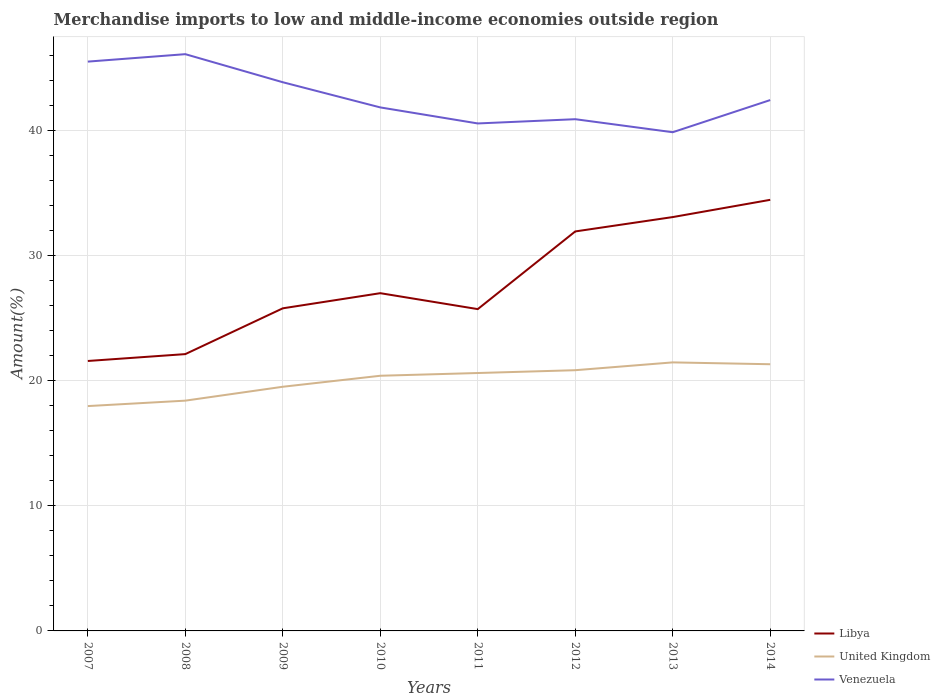Across all years, what is the maximum percentage of amount earned from merchandise imports in Libya?
Provide a short and direct response. 21.59. What is the total percentage of amount earned from merchandise imports in United Kingdom in the graph?
Your answer should be compact. -0.22. What is the difference between the highest and the second highest percentage of amount earned from merchandise imports in Libya?
Offer a terse response. 12.89. What is the difference between the highest and the lowest percentage of amount earned from merchandise imports in Libya?
Make the answer very short. 3. Is the percentage of amount earned from merchandise imports in United Kingdom strictly greater than the percentage of amount earned from merchandise imports in Libya over the years?
Make the answer very short. Yes. How many lines are there?
Your answer should be compact. 3. What is the difference between two consecutive major ticks on the Y-axis?
Make the answer very short. 10. What is the title of the graph?
Give a very brief answer. Merchandise imports to low and middle-income economies outside region. Does "High income: OECD" appear as one of the legend labels in the graph?
Keep it short and to the point. No. What is the label or title of the Y-axis?
Keep it short and to the point. Amount(%). What is the Amount(%) in Libya in 2007?
Offer a very short reply. 21.59. What is the Amount(%) in United Kingdom in 2007?
Offer a very short reply. 17.98. What is the Amount(%) in Venezuela in 2007?
Ensure brevity in your answer.  45.54. What is the Amount(%) of Libya in 2008?
Give a very brief answer. 22.14. What is the Amount(%) in United Kingdom in 2008?
Provide a short and direct response. 18.42. What is the Amount(%) of Venezuela in 2008?
Make the answer very short. 46.13. What is the Amount(%) of Libya in 2009?
Provide a short and direct response. 25.81. What is the Amount(%) in United Kingdom in 2009?
Your response must be concise. 19.53. What is the Amount(%) of Venezuela in 2009?
Offer a very short reply. 43.89. What is the Amount(%) in Libya in 2010?
Your answer should be compact. 27.02. What is the Amount(%) of United Kingdom in 2010?
Your answer should be very brief. 20.41. What is the Amount(%) of Venezuela in 2010?
Provide a short and direct response. 41.87. What is the Amount(%) of Libya in 2011?
Provide a succinct answer. 25.74. What is the Amount(%) in United Kingdom in 2011?
Provide a succinct answer. 20.63. What is the Amount(%) of Venezuela in 2011?
Your answer should be compact. 40.59. What is the Amount(%) in Libya in 2012?
Offer a terse response. 31.95. What is the Amount(%) in United Kingdom in 2012?
Your response must be concise. 20.85. What is the Amount(%) of Venezuela in 2012?
Ensure brevity in your answer.  40.93. What is the Amount(%) of Libya in 2013?
Your answer should be compact. 33.1. What is the Amount(%) in United Kingdom in 2013?
Offer a very short reply. 21.48. What is the Amount(%) in Venezuela in 2013?
Your answer should be very brief. 39.89. What is the Amount(%) of Libya in 2014?
Offer a very short reply. 34.48. What is the Amount(%) in United Kingdom in 2014?
Provide a succinct answer. 21.33. What is the Amount(%) of Venezuela in 2014?
Keep it short and to the point. 42.46. Across all years, what is the maximum Amount(%) of Libya?
Give a very brief answer. 34.48. Across all years, what is the maximum Amount(%) in United Kingdom?
Give a very brief answer. 21.48. Across all years, what is the maximum Amount(%) of Venezuela?
Your answer should be compact. 46.13. Across all years, what is the minimum Amount(%) in Libya?
Your answer should be very brief. 21.59. Across all years, what is the minimum Amount(%) of United Kingdom?
Ensure brevity in your answer.  17.98. Across all years, what is the minimum Amount(%) of Venezuela?
Provide a short and direct response. 39.89. What is the total Amount(%) of Libya in the graph?
Provide a short and direct response. 221.84. What is the total Amount(%) of United Kingdom in the graph?
Keep it short and to the point. 160.64. What is the total Amount(%) in Venezuela in the graph?
Keep it short and to the point. 341.31. What is the difference between the Amount(%) in Libya in 2007 and that in 2008?
Provide a succinct answer. -0.55. What is the difference between the Amount(%) in United Kingdom in 2007 and that in 2008?
Ensure brevity in your answer.  -0.43. What is the difference between the Amount(%) of Venezuela in 2007 and that in 2008?
Keep it short and to the point. -0.59. What is the difference between the Amount(%) of Libya in 2007 and that in 2009?
Your response must be concise. -4.21. What is the difference between the Amount(%) of United Kingdom in 2007 and that in 2009?
Make the answer very short. -1.55. What is the difference between the Amount(%) in Venezuela in 2007 and that in 2009?
Offer a very short reply. 1.65. What is the difference between the Amount(%) in Libya in 2007 and that in 2010?
Provide a succinct answer. -5.42. What is the difference between the Amount(%) in United Kingdom in 2007 and that in 2010?
Offer a terse response. -2.43. What is the difference between the Amount(%) of Venezuela in 2007 and that in 2010?
Provide a short and direct response. 3.66. What is the difference between the Amount(%) of Libya in 2007 and that in 2011?
Offer a terse response. -4.15. What is the difference between the Amount(%) in United Kingdom in 2007 and that in 2011?
Your answer should be very brief. -2.64. What is the difference between the Amount(%) in Venezuela in 2007 and that in 2011?
Your answer should be very brief. 4.95. What is the difference between the Amount(%) of Libya in 2007 and that in 2012?
Your response must be concise. -10.36. What is the difference between the Amount(%) in United Kingdom in 2007 and that in 2012?
Give a very brief answer. -2.87. What is the difference between the Amount(%) in Venezuela in 2007 and that in 2012?
Keep it short and to the point. 4.61. What is the difference between the Amount(%) of Libya in 2007 and that in 2013?
Ensure brevity in your answer.  -11.51. What is the difference between the Amount(%) in United Kingdom in 2007 and that in 2013?
Your answer should be compact. -3.49. What is the difference between the Amount(%) in Venezuela in 2007 and that in 2013?
Your answer should be compact. 5.65. What is the difference between the Amount(%) of Libya in 2007 and that in 2014?
Make the answer very short. -12.89. What is the difference between the Amount(%) in United Kingdom in 2007 and that in 2014?
Your response must be concise. -3.35. What is the difference between the Amount(%) in Venezuela in 2007 and that in 2014?
Give a very brief answer. 3.08. What is the difference between the Amount(%) of Libya in 2008 and that in 2009?
Make the answer very short. -3.66. What is the difference between the Amount(%) in United Kingdom in 2008 and that in 2009?
Give a very brief answer. -1.11. What is the difference between the Amount(%) in Venezuela in 2008 and that in 2009?
Offer a very short reply. 2.24. What is the difference between the Amount(%) of Libya in 2008 and that in 2010?
Your response must be concise. -4.87. What is the difference between the Amount(%) of United Kingdom in 2008 and that in 2010?
Make the answer very short. -1.99. What is the difference between the Amount(%) in Venezuela in 2008 and that in 2010?
Your response must be concise. 4.26. What is the difference between the Amount(%) in Libya in 2008 and that in 2011?
Keep it short and to the point. -3.6. What is the difference between the Amount(%) in United Kingdom in 2008 and that in 2011?
Ensure brevity in your answer.  -2.21. What is the difference between the Amount(%) of Venezuela in 2008 and that in 2011?
Your answer should be compact. 5.54. What is the difference between the Amount(%) of Libya in 2008 and that in 2012?
Provide a short and direct response. -9.81. What is the difference between the Amount(%) in United Kingdom in 2008 and that in 2012?
Make the answer very short. -2.44. What is the difference between the Amount(%) of Venezuela in 2008 and that in 2012?
Your answer should be compact. 5.2. What is the difference between the Amount(%) of Libya in 2008 and that in 2013?
Your answer should be compact. -10.96. What is the difference between the Amount(%) of United Kingdom in 2008 and that in 2013?
Ensure brevity in your answer.  -3.06. What is the difference between the Amount(%) of Venezuela in 2008 and that in 2013?
Provide a short and direct response. 6.24. What is the difference between the Amount(%) of Libya in 2008 and that in 2014?
Offer a terse response. -12.34. What is the difference between the Amount(%) in United Kingdom in 2008 and that in 2014?
Provide a succinct answer. -2.91. What is the difference between the Amount(%) of Venezuela in 2008 and that in 2014?
Make the answer very short. 3.67. What is the difference between the Amount(%) in Libya in 2009 and that in 2010?
Make the answer very short. -1.21. What is the difference between the Amount(%) of United Kingdom in 2009 and that in 2010?
Offer a terse response. -0.88. What is the difference between the Amount(%) of Venezuela in 2009 and that in 2010?
Ensure brevity in your answer.  2.01. What is the difference between the Amount(%) in Libya in 2009 and that in 2011?
Ensure brevity in your answer.  0.06. What is the difference between the Amount(%) in United Kingdom in 2009 and that in 2011?
Keep it short and to the point. -1.1. What is the difference between the Amount(%) in Venezuela in 2009 and that in 2011?
Keep it short and to the point. 3.3. What is the difference between the Amount(%) of Libya in 2009 and that in 2012?
Your answer should be compact. -6.15. What is the difference between the Amount(%) of United Kingdom in 2009 and that in 2012?
Offer a terse response. -1.32. What is the difference between the Amount(%) in Venezuela in 2009 and that in 2012?
Keep it short and to the point. 2.96. What is the difference between the Amount(%) in Libya in 2009 and that in 2013?
Give a very brief answer. -7.3. What is the difference between the Amount(%) of United Kingdom in 2009 and that in 2013?
Keep it short and to the point. -1.95. What is the difference between the Amount(%) of Venezuela in 2009 and that in 2013?
Your answer should be very brief. 4. What is the difference between the Amount(%) in Libya in 2009 and that in 2014?
Your response must be concise. -8.68. What is the difference between the Amount(%) of United Kingdom in 2009 and that in 2014?
Your answer should be compact. -1.8. What is the difference between the Amount(%) of Venezuela in 2009 and that in 2014?
Your answer should be very brief. 1.43. What is the difference between the Amount(%) of Libya in 2010 and that in 2011?
Your answer should be very brief. 1.27. What is the difference between the Amount(%) of United Kingdom in 2010 and that in 2011?
Your answer should be very brief. -0.22. What is the difference between the Amount(%) of Venezuela in 2010 and that in 2011?
Provide a succinct answer. 1.28. What is the difference between the Amount(%) in Libya in 2010 and that in 2012?
Offer a terse response. -4.94. What is the difference between the Amount(%) of United Kingdom in 2010 and that in 2012?
Give a very brief answer. -0.44. What is the difference between the Amount(%) of Venezuela in 2010 and that in 2012?
Your answer should be compact. 0.94. What is the difference between the Amount(%) of Libya in 2010 and that in 2013?
Keep it short and to the point. -6.09. What is the difference between the Amount(%) in United Kingdom in 2010 and that in 2013?
Provide a short and direct response. -1.07. What is the difference between the Amount(%) of Venezuela in 2010 and that in 2013?
Your answer should be compact. 1.98. What is the difference between the Amount(%) in Libya in 2010 and that in 2014?
Ensure brevity in your answer.  -7.47. What is the difference between the Amount(%) in United Kingdom in 2010 and that in 2014?
Your answer should be compact. -0.92. What is the difference between the Amount(%) in Venezuela in 2010 and that in 2014?
Your answer should be compact. -0.59. What is the difference between the Amount(%) in Libya in 2011 and that in 2012?
Offer a terse response. -6.21. What is the difference between the Amount(%) of United Kingdom in 2011 and that in 2012?
Ensure brevity in your answer.  -0.23. What is the difference between the Amount(%) of Venezuela in 2011 and that in 2012?
Provide a succinct answer. -0.34. What is the difference between the Amount(%) in Libya in 2011 and that in 2013?
Provide a short and direct response. -7.36. What is the difference between the Amount(%) in United Kingdom in 2011 and that in 2013?
Provide a succinct answer. -0.85. What is the difference between the Amount(%) in Venezuela in 2011 and that in 2013?
Your answer should be very brief. 0.7. What is the difference between the Amount(%) of Libya in 2011 and that in 2014?
Offer a very short reply. -8.74. What is the difference between the Amount(%) of United Kingdom in 2011 and that in 2014?
Offer a very short reply. -0.7. What is the difference between the Amount(%) in Venezuela in 2011 and that in 2014?
Provide a short and direct response. -1.87. What is the difference between the Amount(%) in Libya in 2012 and that in 2013?
Give a very brief answer. -1.15. What is the difference between the Amount(%) of United Kingdom in 2012 and that in 2013?
Provide a short and direct response. -0.62. What is the difference between the Amount(%) of Venezuela in 2012 and that in 2013?
Offer a very short reply. 1.04. What is the difference between the Amount(%) in Libya in 2012 and that in 2014?
Your answer should be compact. -2.53. What is the difference between the Amount(%) in United Kingdom in 2012 and that in 2014?
Provide a short and direct response. -0.48. What is the difference between the Amount(%) in Venezuela in 2012 and that in 2014?
Your answer should be very brief. -1.53. What is the difference between the Amount(%) in Libya in 2013 and that in 2014?
Your answer should be very brief. -1.38. What is the difference between the Amount(%) of United Kingdom in 2013 and that in 2014?
Your answer should be very brief. 0.15. What is the difference between the Amount(%) of Venezuela in 2013 and that in 2014?
Offer a very short reply. -2.57. What is the difference between the Amount(%) of Libya in 2007 and the Amount(%) of United Kingdom in 2008?
Give a very brief answer. 3.17. What is the difference between the Amount(%) in Libya in 2007 and the Amount(%) in Venezuela in 2008?
Give a very brief answer. -24.54. What is the difference between the Amount(%) of United Kingdom in 2007 and the Amount(%) of Venezuela in 2008?
Your answer should be very brief. -28.15. What is the difference between the Amount(%) in Libya in 2007 and the Amount(%) in United Kingdom in 2009?
Make the answer very short. 2.06. What is the difference between the Amount(%) in Libya in 2007 and the Amount(%) in Venezuela in 2009?
Make the answer very short. -22.3. What is the difference between the Amount(%) of United Kingdom in 2007 and the Amount(%) of Venezuela in 2009?
Provide a short and direct response. -25.9. What is the difference between the Amount(%) of Libya in 2007 and the Amount(%) of United Kingdom in 2010?
Make the answer very short. 1.18. What is the difference between the Amount(%) in Libya in 2007 and the Amount(%) in Venezuela in 2010?
Offer a terse response. -20.28. What is the difference between the Amount(%) in United Kingdom in 2007 and the Amount(%) in Venezuela in 2010?
Your answer should be very brief. -23.89. What is the difference between the Amount(%) in Libya in 2007 and the Amount(%) in United Kingdom in 2011?
Provide a short and direct response. 0.96. What is the difference between the Amount(%) of Libya in 2007 and the Amount(%) of Venezuela in 2011?
Give a very brief answer. -19. What is the difference between the Amount(%) in United Kingdom in 2007 and the Amount(%) in Venezuela in 2011?
Keep it short and to the point. -22.61. What is the difference between the Amount(%) of Libya in 2007 and the Amount(%) of United Kingdom in 2012?
Offer a terse response. 0.74. What is the difference between the Amount(%) in Libya in 2007 and the Amount(%) in Venezuela in 2012?
Offer a terse response. -19.34. What is the difference between the Amount(%) of United Kingdom in 2007 and the Amount(%) of Venezuela in 2012?
Ensure brevity in your answer.  -22.95. What is the difference between the Amount(%) of Libya in 2007 and the Amount(%) of United Kingdom in 2013?
Your response must be concise. 0.11. What is the difference between the Amount(%) of Libya in 2007 and the Amount(%) of Venezuela in 2013?
Provide a succinct answer. -18.3. What is the difference between the Amount(%) in United Kingdom in 2007 and the Amount(%) in Venezuela in 2013?
Keep it short and to the point. -21.91. What is the difference between the Amount(%) of Libya in 2007 and the Amount(%) of United Kingdom in 2014?
Your answer should be compact. 0.26. What is the difference between the Amount(%) in Libya in 2007 and the Amount(%) in Venezuela in 2014?
Give a very brief answer. -20.87. What is the difference between the Amount(%) of United Kingdom in 2007 and the Amount(%) of Venezuela in 2014?
Provide a succinct answer. -24.48. What is the difference between the Amount(%) of Libya in 2008 and the Amount(%) of United Kingdom in 2009?
Your answer should be very brief. 2.61. What is the difference between the Amount(%) of Libya in 2008 and the Amount(%) of Venezuela in 2009?
Your response must be concise. -21.75. What is the difference between the Amount(%) of United Kingdom in 2008 and the Amount(%) of Venezuela in 2009?
Your answer should be very brief. -25.47. What is the difference between the Amount(%) in Libya in 2008 and the Amount(%) in United Kingdom in 2010?
Provide a short and direct response. 1.73. What is the difference between the Amount(%) in Libya in 2008 and the Amount(%) in Venezuela in 2010?
Your answer should be compact. -19.73. What is the difference between the Amount(%) of United Kingdom in 2008 and the Amount(%) of Venezuela in 2010?
Provide a short and direct response. -23.46. What is the difference between the Amount(%) of Libya in 2008 and the Amount(%) of United Kingdom in 2011?
Your response must be concise. 1.51. What is the difference between the Amount(%) of Libya in 2008 and the Amount(%) of Venezuela in 2011?
Provide a succinct answer. -18.45. What is the difference between the Amount(%) of United Kingdom in 2008 and the Amount(%) of Venezuela in 2011?
Your answer should be compact. -22.17. What is the difference between the Amount(%) of Libya in 2008 and the Amount(%) of United Kingdom in 2012?
Your response must be concise. 1.29. What is the difference between the Amount(%) in Libya in 2008 and the Amount(%) in Venezuela in 2012?
Make the answer very short. -18.79. What is the difference between the Amount(%) of United Kingdom in 2008 and the Amount(%) of Venezuela in 2012?
Your answer should be very brief. -22.51. What is the difference between the Amount(%) of Libya in 2008 and the Amount(%) of United Kingdom in 2013?
Make the answer very short. 0.66. What is the difference between the Amount(%) of Libya in 2008 and the Amount(%) of Venezuela in 2013?
Ensure brevity in your answer.  -17.75. What is the difference between the Amount(%) in United Kingdom in 2008 and the Amount(%) in Venezuela in 2013?
Keep it short and to the point. -21.47. What is the difference between the Amount(%) of Libya in 2008 and the Amount(%) of United Kingdom in 2014?
Offer a very short reply. 0.81. What is the difference between the Amount(%) in Libya in 2008 and the Amount(%) in Venezuela in 2014?
Provide a short and direct response. -20.32. What is the difference between the Amount(%) of United Kingdom in 2008 and the Amount(%) of Venezuela in 2014?
Offer a very short reply. -24.04. What is the difference between the Amount(%) in Libya in 2009 and the Amount(%) in United Kingdom in 2010?
Your answer should be very brief. 5.39. What is the difference between the Amount(%) of Libya in 2009 and the Amount(%) of Venezuela in 2010?
Your answer should be very brief. -16.07. What is the difference between the Amount(%) of United Kingdom in 2009 and the Amount(%) of Venezuela in 2010?
Offer a very short reply. -22.34. What is the difference between the Amount(%) in Libya in 2009 and the Amount(%) in United Kingdom in 2011?
Your response must be concise. 5.18. What is the difference between the Amount(%) in Libya in 2009 and the Amount(%) in Venezuela in 2011?
Provide a succinct answer. -14.79. What is the difference between the Amount(%) of United Kingdom in 2009 and the Amount(%) of Venezuela in 2011?
Ensure brevity in your answer.  -21.06. What is the difference between the Amount(%) of Libya in 2009 and the Amount(%) of United Kingdom in 2012?
Keep it short and to the point. 4.95. What is the difference between the Amount(%) in Libya in 2009 and the Amount(%) in Venezuela in 2012?
Ensure brevity in your answer.  -15.13. What is the difference between the Amount(%) in United Kingdom in 2009 and the Amount(%) in Venezuela in 2012?
Provide a short and direct response. -21.4. What is the difference between the Amount(%) in Libya in 2009 and the Amount(%) in United Kingdom in 2013?
Your answer should be very brief. 4.33. What is the difference between the Amount(%) of Libya in 2009 and the Amount(%) of Venezuela in 2013?
Make the answer very short. -14.09. What is the difference between the Amount(%) in United Kingdom in 2009 and the Amount(%) in Venezuela in 2013?
Offer a very short reply. -20.36. What is the difference between the Amount(%) in Libya in 2009 and the Amount(%) in United Kingdom in 2014?
Make the answer very short. 4.47. What is the difference between the Amount(%) of Libya in 2009 and the Amount(%) of Venezuela in 2014?
Your answer should be very brief. -16.66. What is the difference between the Amount(%) of United Kingdom in 2009 and the Amount(%) of Venezuela in 2014?
Provide a short and direct response. -22.93. What is the difference between the Amount(%) of Libya in 2010 and the Amount(%) of United Kingdom in 2011?
Your answer should be very brief. 6.39. What is the difference between the Amount(%) of Libya in 2010 and the Amount(%) of Venezuela in 2011?
Keep it short and to the point. -13.58. What is the difference between the Amount(%) of United Kingdom in 2010 and the Amount(%) of Venezuela in 2011?
Provide a short and direct response. -20.18. What is the difference between the Amount(%) of Libya in 2010 and the Amount(%) of United Kingdom in 2012?
Make the answer very short. 6.16. What is the difference between the Amount(%) of Libya in 2010 and the Amount(%) of Venezuela in 2012?
Ensure brevity in your answer.  -13.92. What is the difference between the Amount(%) of United Kingdom in 2010 and the Amount(%) of Venezuela in 2012?
Ensure brevity in your answer.  -20.52. What is the difference between the Amount(%) in Libya in 2010 and the Amount(%) in United Kingdom in 2013?
Provide a short and direct response. 5.54. What is the difference between the Amount(%) of Libya in 2010 and the Amount(%) of Venezuela in 2013?
Make the answer very short. -12.87. What is the difference between the Amount(%) in United Kingdom in 2010 and the Amount(%) in Venezuela in 2013?
Your answer should be very brief. -19.48. What is the difference between the Amount(%) in Libya in 2010 and the Amount(%) in United Kingdom in 2014?
Your response must be concise. 5.68. What is the difference between the Amount(%) of Libya in 2010 and the Amount(%) of Venezuela in 2014?
Your response must be concise. -15.45. What is the difference between the Amount(%) of United Kingdom in 2010 and the Amount(%) of Venezuela in 2014?
Offer a terse response. -22.05. What is the difference between the Amount(%) in Libya in 2011 and the Amount(%) in United Kingdom in 2012?
Give a very brief answer. 4.89. What is the difference between the Amount(%) in Libya in 2011 and the Amount(%) in Venezuela in 2012?
Give a very brief answer. -15.19. What is the difference between the Amount(%) in United Kingdom in 2011 and the Amount(%) in Venezuela in 2012?
Your answer should be very brief. -20.3. What is the difference between the Amount(%) of Libya in 2011 and the Amount(%) of United Kingdom in 2013?
Your answer should be compact. 4.26. What is the difference between the Amount(%) of Libya in 2011 and the Amount(%) of Venezuela in 2013?
Offer a terse response. -14.15. What is the difference between the Amount(%) of United Kingdom in 2011 and the Amount(%) of Venezuela in 2013?
Offer a very short reply. -19.26. What is the difference between the Amount(%) in Libya in 2011 and the Amount(%) in United Kingdom in 2014?
Give a very brief answer. 4.41. What is the difference between the Amount(%) of Libya in 2011 and the Amount(%) of Venezuela in 2014?
Offer a terse response. -16.72. What is the difference between the Amount(%) in United Kingdom in 2011 and the Amount(%) in Venezuela in 2014?
Keep it short and to the point. -21.83. What is the difference between the Amount(%) of Libya in 2012 and the Amount(%) of United Kingdom in 2013?
Your answer should be compact. 10.47. What is the difference between the Amount(%) in Libya in 2012 and the Amount(%) in Venezuela in 2013?
Offer a terse response. -7.94. What is the difference between the Amount(%) in United Kingdom in 2012 and the Amount(%) in Venezuela in 2013?
Your answer should be very brief. -19.04. What is the difference between the Amount(%) of Libya in 2012 and the Amount(%) of United Kingdom in 2014?
Offer a terse response. 10.62. What is the difference between the Amount(%) in Libya in 2012 and the Amount(%) in Venezuela in 2014?
Make the answer very short. -10.51. What is the difference between the Amount(%) in United Kingdom in 2012 and the Amount(%) in Venezuela in 2014?
Your answer should be compact. -21.61. What is the difference between the Amount(%) of Libya in 2013 and the Amount(%) of United Kingdom in 2014?
Give a very brief answer. 11.77. What is the difference between the Amount(%) in Libya in 2013 and the Amount(%) in Venezuela in 2014?
Your answer should be compact. -9.36. What is the difference between the Amount(%) of United Kingdom in 2013 and the Amount(%) of Venezuela in 2014?
Your answer should be very brief. -20.98. What is the average Amount(%) of Libya per year?
Your answer should be compact. 27.73. What is the average Amount(%) of United Kingdom per year?
Give a very brief answer. 20.08. What is the average Amount(%) of Venezuela per year?
Provide a short and direct response. 42.66. In the year 2007, what is the difference between the Amount(%) of Libya and Amount(%) of United Kingdom?
Your answer should be compact. 3.61. In the year 2007, what is the difference between the Amount(%) of Libya and Amount(%) of Venezuela?
Make the answer very short. -23.95. In the year 2007, what is the difference between the Amount(%) of United Kingdom and Amount(%) of Venezuela?
Provide a succinct answer. -27.55. In the year 2008, what is the difference between the Amount(%) of Libya and Amount(%) of United Kingdom?
Give a very brief answer. 3.72. In the year 2008, what is the difference between the Amount(%) of Libya and Amount(%) of Venezuela?
Your response must be concise. -23.99. In the year 2008, what is the difference between the Amount(%) of United Kingdom and Amount(%) of Venezuela?
Your answer should be very brief. -27.71. In the year 2009, what is the difference between the Amount(%) of Libya and Amount(%) of United Kingdom?
Your answer should be very brief. 6.27. In the year 2009, what is the difference between the Amount(%) in Libya and Amount(%) in Venezuela?
Keep it short and to the point. -18.08. In the year 2009, what is the difference between the Amount(%) in United Kingdom and Amount(%) in Venezuela?
Provide a succinct answer. -24.36. In the year 2010, what is the difference between the Amount(%) of Libya and Amount(%) of United Kingdom?
Keep it short and to the point. 6.6. In the year 2010, what is the difference between the Amount(%) of Libya and Amount(%) of Venezuela?
Ensure brevity in your answer.  -14.86. In the year 2010, what is the difference between the Amount(%) of United Kingdom and Amount(%) of Venezuela?
Provide a short and direct response. -21.46. In the year 2011, what is the difference between the Amount(%) of Libya and Amount(%) of United Kingdom?
Your answer should be compact. 5.11. In the year 2011, what is the difference between the Amount(%) of Libya and Amount(%) of Venezuela?
Ensure brevity in your answer.  -14.85. In the year 2011, what is the difference between the Amount(%) in United Kingdom and Amount(%) in Venezuela?
Ensure brevity in your answer.  -19.96. In the year 2012, what is the difference between the Amount(%) of Libya and Amount(%) of United Kingdom?
Your response must be concise. 11.1. In the year 2012, what is the difference between the Amount(%) in Libya and Amount(%) in Venezuela?
Your response must be concise. -8.98. In the year 2012, what is the difference between the Amount(%) of United Kingdom and Amount(%) of Venezuela?
Your response must be concise. -20.08. In the year 2013, what is the difference between the Amount(%) in Libya and Amount(%) in United Kingdom?
Provide a short and direct response. 11.62. In the year 2013, what is the difference between the Amount(%) of Libya and Amount(%) of Venezuela?
Your response must be concise. -6.79. In the year 2013, what is the difference between the Amount(%) in United Kingdom and Amount(%) in Venezuela?
Provide a short and direct response. -18.41. In the year 2014, what is the difference between the Amount(%) of Libya and Amount(%) of United Kingdom?
Provide a succinct answer. 13.15. In the year 2014, what is the difference between the Amount(%) of Libya and Amount(%) of Venezuela?
Keep it short and to the point. -7.98. In the year 2014, what is the difference between the Amount(%) of United Kingdom and Amount(%) of Venezuela?
Give a very brief answer. -21.13. What is the ratio of the Amount(%) of Libya in 2007 to that in 2008?
Provide a succinct answer. 0.98. What is the ratio of the Amount(%) in United Kingdom in 2007 to that in 2008?
Your response must be concise. 0.98. What is the ratio of the Amount(%) in Venezuela in 2007 to that in 2008?
Offer a terse response. 0.99. What is the ratio of the Amount(%) in Libya in 2007 to that in 2009?
Make the answer very short. 0.84. What is the ratio of the Amount(%) in United Kingdom in 2007 to that in 2009?
Provide a succinct answer. 0.92. What is the ratio of the Amount(%) in Venezuela in 2007 to that in 2009?
Offer a terse response. 1.04. What is the ratio of the Amount(%) of Libya in 2007 to that in 2010?
Your answer should be compact. 0.8. What is the ratio of the Amount(%) in United Kingdom in 2007 to that in 2010?
Your answer should be compact. 0.88. What is the ratio of the Amount(%) of Venezuela in 2007 to that in 2010?
Your answer should be very brief. 1.09. What is the ratio of the Amount(%) of Libya in 2007 to that in 2011?
Keep it short and to the point. 0.84. What is the ratio of the Amount(%) in United Kingdom in 2007 to that in 2011?
Give a very brief answer. 0.87. What is the ratio of the Amount(%) in Venezuela in 2007 to that in 2011?
Keep it short and to the point. 1.12. What is the ratio of the Amount(%) of Libya in 2007 to that in 2012?
Provide a short and direct response. 0.68. What is the ratio of the Amount(%) of United Kingdom in 2007 to that in 2012?
Offer a terse response. 0.86. What is the ratio of the Amount(%) in Venezuela in 2007 to that in 2012?
Your answer should be very brief. 1.11. What is the ratio of the Amount(%) of Libya in 2007 to that in 2013?
Offer a very short reply. 0.65. What is the ratio of the Amount(%) of United Kingdom in 2007 to that in 2013?
Your answer should be very brief. 0.84. What is the ratio of the Amount(%) in Venezuela in 2007 to that in 2013?
Ensure brevity in your answer.  1.14. What is the ratio of the Amount(%) in Libya in 2007 to that in 2014?
Provide a succinct answer. 0.63. What is the ratio of the Amount(%) of United Kingdom in 2007 to that in 2014?
Provide a succinct answer. 0.84. What is the ratio of the Amount(%) of Venezuela in 2007 to that in 2014?
Give a very brief answer. 1.07. What is the ratio of the Amount(%) in Libya in 2008 to that in 2009?
Keep it short and to the point. 0.86. What is the ratio of the Amount(%) of United Kingdom in 2008 to that in 2009?
Your response must be concise. 0.94. What is the ratio of the Amount(%) of Venezuela in 2008 to that in 2009?
Keep it short and to the point. 1.05. What is the ratio of the Amount(%) in Libya in 2008 to that in 2010?
Give a very brief answer. 0.82. What is the ratio of the Amount(%) of United Kingdom in 2008 to that in 2010?
Offer a terse response. 0.9. What is the ratio of the Amount(%) in Venezuela in 2008 to that in 2010?
Provide a succinct answer. 1.1. What is the ratio of the Amount(%) in Libya in 2008 to that in 2011?
Provide a short and direct response. 0.86. What is the ratio of the Amount(%) of United Kingdom in 2008 to that in 2011?
Keep it short and to the point. 0.89. What is the ratio of the Amount(%) of Venezuela in 2008 to that in 2011?
Give a very brief answer. 1.14. What is the ratio of the Amount(%) of Libya in 2008 to that in 2012?
Give a very brief answer. 0.69. What is the ratio of the Amount(%) of United Kingdom in 2008 to that in 2012?
Provide a short and direct response. 0.88. What is the ratio of the Amount(%) of Venezuela in 2008 to that in 2012?
Keep it short and to the point. 1.13. What is the ratio of the Amount(%) of Libya in 2008 to that in 2013?
Provide a short and direct response. 0.67. What is the ratio of the Amount(%) in United Kingdom in 2008 to that in 2013?
Offer a very short reply. 0.86. What is the ratio of the Amount(%) of Venezuela in 2008 to that in 2013?
Your answer should be compact. 1.16. What is the ratio of the Amount(%) in Libya in 2008 to that in 2014?
Your answer should be very brief. 0.64. What is the ratio of the Amount(%) of United Kingdom in 2008 to that in 2014?
Give a very brief answer. 0.86. What is the ratio of the Amount(%) in Venezuela in 2008 to that in 2014?
Give a very brief answer. 1.09. What is the ratio of the Amount(%) of Libya in 2009 to that in 2010?
Your response must be concise. 0.96. What is the ratio of the Amount(%) of United Kingdom in 2009 to that in 2010?
Your answer should be very brief. 0.96. What is the ratio of the Amount(%) of Venezuela in 2009 to that in 2010?
Make the answer very short. 1.05. What is the ratio of the Amount(%) of Libya in 2009 to that in 2011?
Make the answer very short. 1. What is the ratio of the Amount(%) in United Kingdom in 2009 to that in 2011?
Provide a succinct answer. 0.95. What is the ratio of the Amount(%) of Venezuela in 2009 to that in 2011?
Make the answer very short. 1.08. What is the ratio of the Amount(%) in Libya in 2009 to that in 2012?
Offer a very short reply. 0.81. What is the ratio of the Amount(%) of United Kingdom in 2009 to that in 2012?
Keep it short and to the point. 0.94. What is the ratio of the Amount(%) in Venezuela in 2009 to that in 2012?
Your response must be concise. 1.07. What is the ratio of the Amount(%) in Libya in 2009 to that in 2013?
Offer a terse response. 0.78. What is the ratio of the Amount(%) of United Kingdom in 2009 to that in 2013?
Make the answer very short. 0.91. What is the ratio of the Amount(%) of Venezuela in 2009 to that in 2013?
Your answer should be very brief. 1.1. What is the ratio of the Amount(%) in Libya in 2009 to that in 2014?
Provide a short and direct response. 0.75. What is the ratio of the Amount(%) in United Kingdom in 2009 to that in 2014?
Your answer should be compact. 0.92. What is the ratio of the Amount(%) in Venezuela in 2009 to that in 2014?
Offer a very short reply. 1.03. What is the ratio of the Amount(%) of Libya in 2010 to that in 2011?
Provide a short and direct response. 1.05. What is the ratio of the Amount(%) of Venezuela in 2010 to that in 2011?
Ensure brevity in your answer.  1.03. What is the ratio of the Amount(%) of Libya in 2010 to that in 2012?
Provide a succinct answer. 0.85. What is the ratio of the Amount(%) in United Kingdom in 2010 to that in 2012?
Your answer should be very brief. 0.98. What is the ratio of the Amount(%) of Libya in 2010 to that in 2013?
Offer a very short reply. 0.82. What is the ratio of the Amount(%) in United Kingdom in 2010 to that in 2013?
Provide a short and direct response. 0.95. What is the ratio of the Amount(%) of Venezuela in 2010 to that in 2013?
Your answer should be very brief. 1.05. What is the ratio of the Amount(%) in Libya in 2010 to that in 2014?
Your response must be concise. 0.78. What is the ratio of the Amount(%) in United Kingdom in 2010 to that in 2014?
Provide a succinct answer. 0.96. What is the ratio of the Amount(%) in Venezuela in 2010 to that in 2014?
Offer a terse response. 0.99. What is the ratio of the Amount(%) of Libya in 2011 to that in 2012?
Your answer should be compact. 0.81. What is the ratio of the Amount(%) in United Kingdom in 2011 to that in 2012?
Your answer should be very brief. 0.99. What is the ratio of the Amount(%) of Venezuela in 2011 to that in 2012?
Your answer should be very brief. 0.99. What is the ratio of the Amount(%) in Libya in 2011 to that in 2013?
Provide a succinct answer. 0.78. What is the ratio of the Amount(%) of United Kingdom in 2011 to that in 2013?
Make the answer very short. 0.96. What is the ratio of the Amount(%) of Venezuela in 2011 to that in 2013?
Provide a short and direct response. 1.02. What is the ratio of the Amount(%) in Libya in 2011 to that in 2014?
Your answer should be compact. 0.75. What is the ratio of the Amount(%) in United Kingdom in 2011 to that in 2014?
Offer a very short reply. 0.97. What is the ratio of the Amount(%) of Venezuela in 2011 to that in 2014?
Your response must be concise. 0.96. What is the ratio of the Amount(%) of Libya in 2012 to that in 2013?
Ensure brevity in your answer.  0.97. What is the ratio of the Amount(%) in United Kingdom in 2012 to that in 2013?
Ensure brevity in your answer.  0.97. What is the ratio of the Amount(%) of Venezuela in 2012 to that in 2013?
Ensure brevity in your answer.  1.03. What is the ratio of the Amount(%) of Libya in 2012 to that in 2014?
Offer a very short reply. 0.93. What is the ratio of the Amount(%) in United Kingdom in 2012 to that in 2014?
Your answer should be very brief. 0.98. What is the ratio of the Amount(%) in Venezuela in 2012 to that in 2014?
Provide a short and direct response. 0.96. What is the ratio of the Amount(%) in Libya in 2013 to that in 2014?
Make the answer very short. 0.96. What is the ratio of the Amount(%) in Venezuela in 2013 to that in 2014?
Provide a succinct answer. 0.94. What is the difference between the highest and the second highest Amount(%) in Libya?
Keep it short and to the point. 1.38. What is the difference between the highest and the second highest Amount(%) of United Kingdom?
Your answer should be compact. 0.15. What is the difference between the highest and the second highest Amount(%) in Venezuela?
Ensure brevity in your answer.  0.59. What is the difference between the highest and the lowest Amount(%) in Libya?
Make the answer very short. 12.89. What is the difference between the highest and the lowest Amount(%) in United Kingdom?
Your response must be concise. 3.49. What is the difference between the highest and the lowest Amount(%) of Venezuela?
Your answer should be very brief. 6.24. 